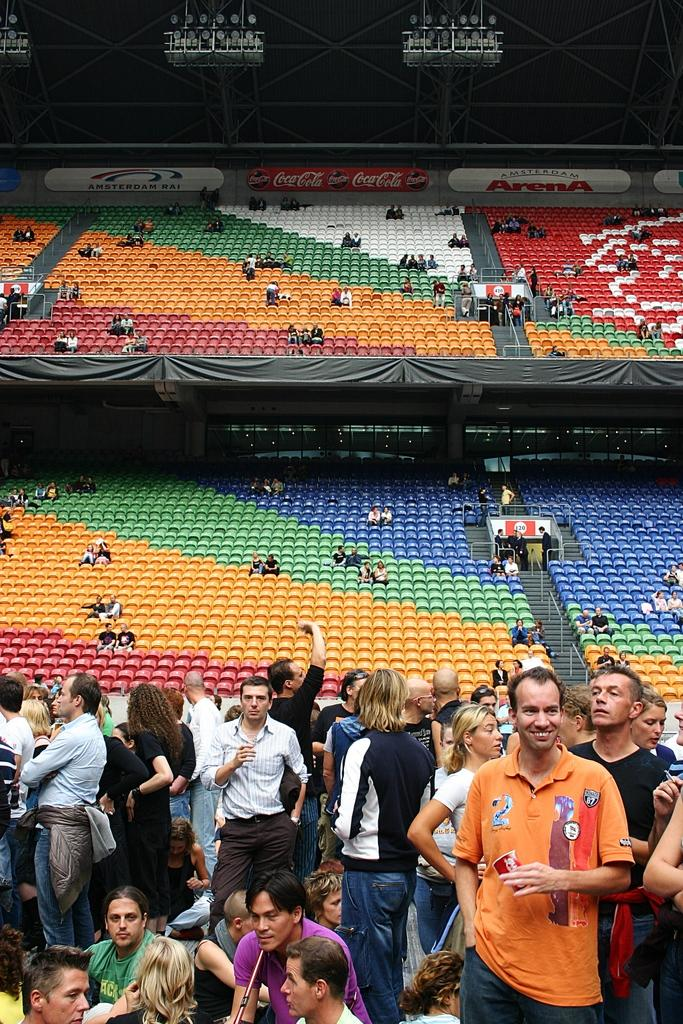Who or what is present in the image? There are people in the image. Where are the people located? The people are in a stadium. Can you describe the seating arrangement in the background? There are people seated in chairs in the background. What type of tiger can be seen roaming around the stadium in the image? There is no tiger present in the image; it features people in a stadium. Can you tell me how many airplanes are flying over the stadium in the image? There are no airplanes visible in the image; it only shows people in a stadium. 